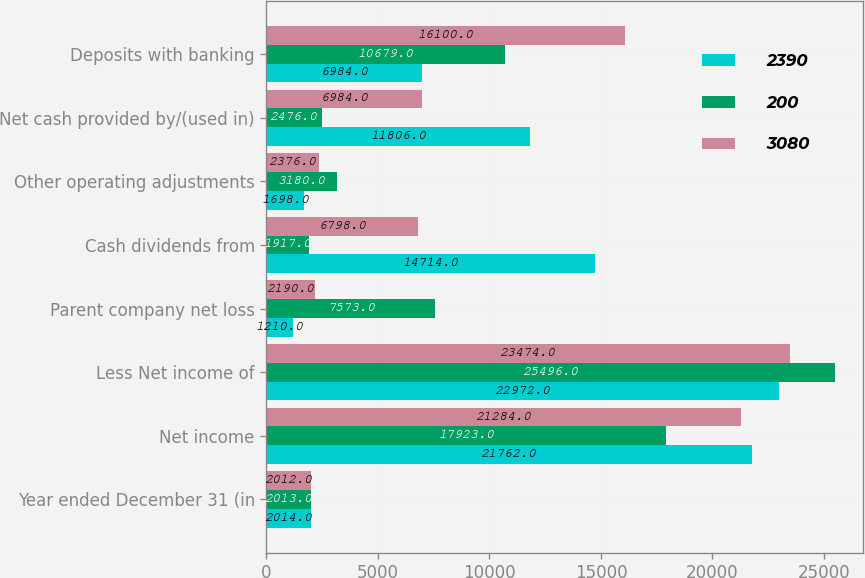Convert chart to OTSL. <chart><loc_0><loc_0><loc_500><loc_500><stacked_bar_chart><ecel><fcel>Year ended December 31 (in<fcel>Net income<fcel>Less Net income of<fcel>Parent company net loss<fcel>Cash dividends from<fcel>Other operating adjustments<fcel>Net cash provided by/(used in)<fcel>Deposits with banking<nl><fcel>2390<fcel>2014<fcel>21762<fcel>22972<fcel>1210<fcel>14714<fcel>1698<fcel>11806<fcel>6984<nl><fcel>200<fcel>2013<fcel>17923<fcel>25496<fcel>7573<fcel>1917<fcel>3180<fcel>2476<fcel>10679<nl><fcel>3080<fcel>2012<fcel>21284<fcel>23474<fcel>2190<fcel>6798<fcel>2376<fcel>6984<fcel>16100<nl></chart> 